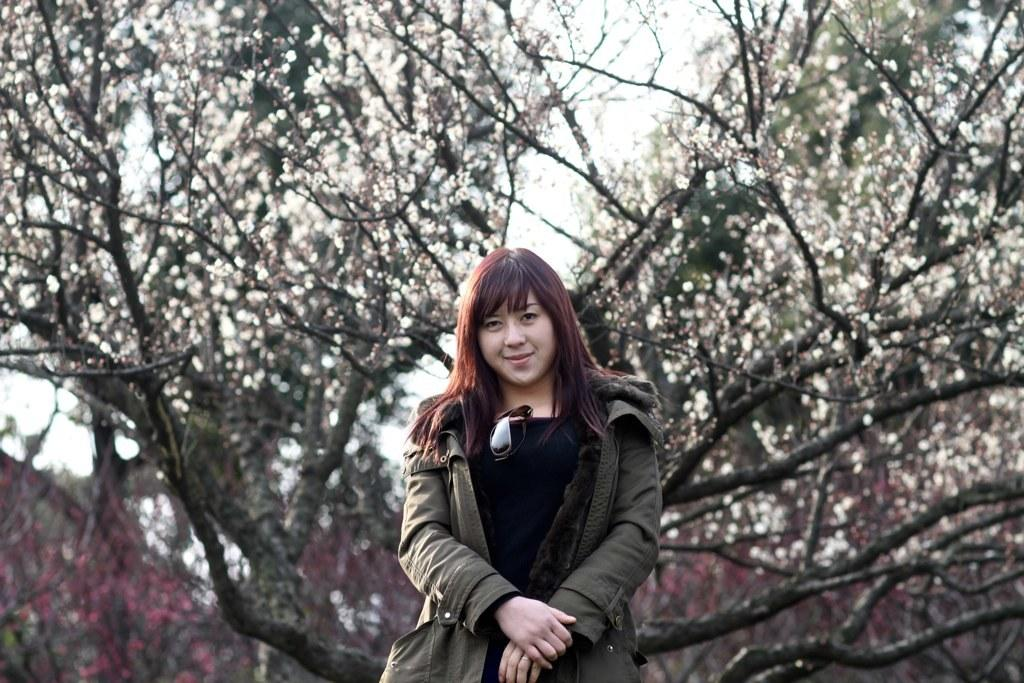What is the main subject of the image? There is a woman standing in the image. What is the woman wearing? The woman is wearing a jacket. What can be seen in the background of the image? There are trees and the sky visible in the background of the image. What direction is the sail moving in the image? There is no sail present in the image. What might surprise the woman in the image? The image does not provide any information about what might surprise the woman, as it only shows her standing and wearing a jacket. 